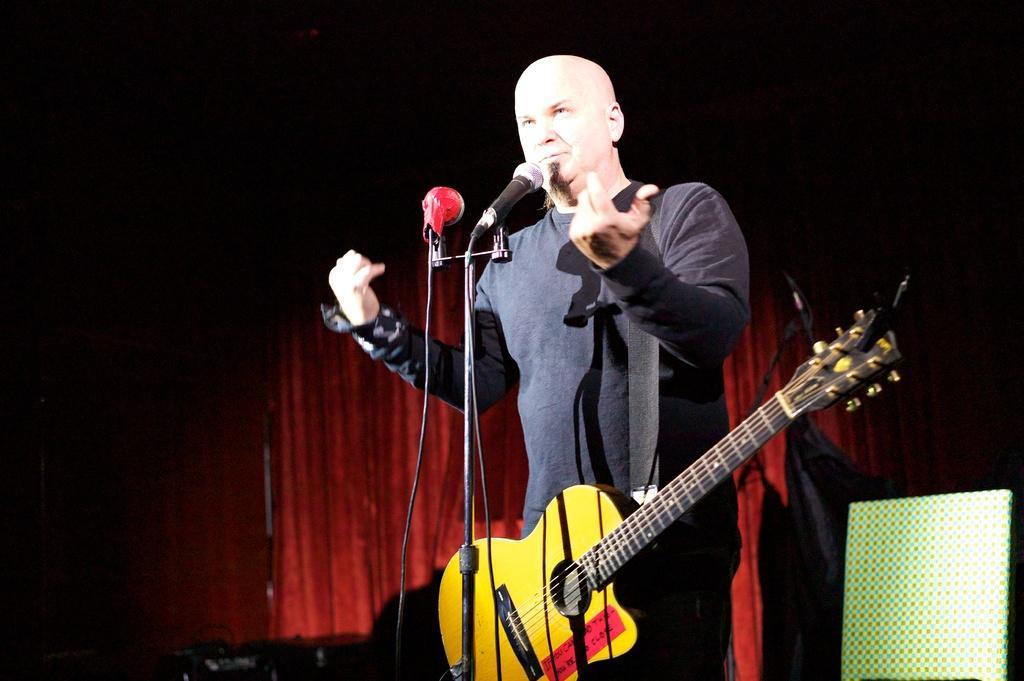In one or two sentences, can you explain what this image depicts? Here we can see a man who is singing on the mike. He is holding a guitar. On the background we can see a curtain. 